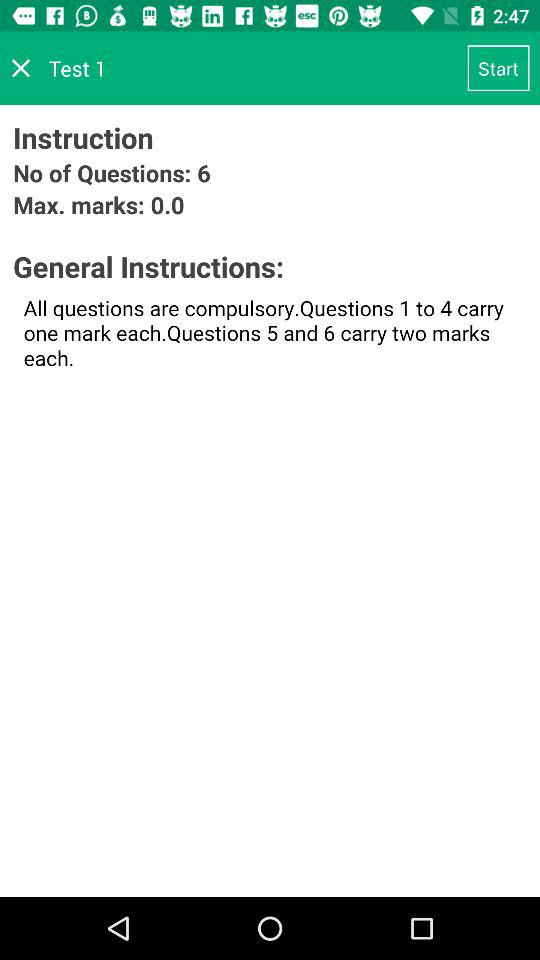How much is the "Max. marks"? The maximum marks are 0.0. 